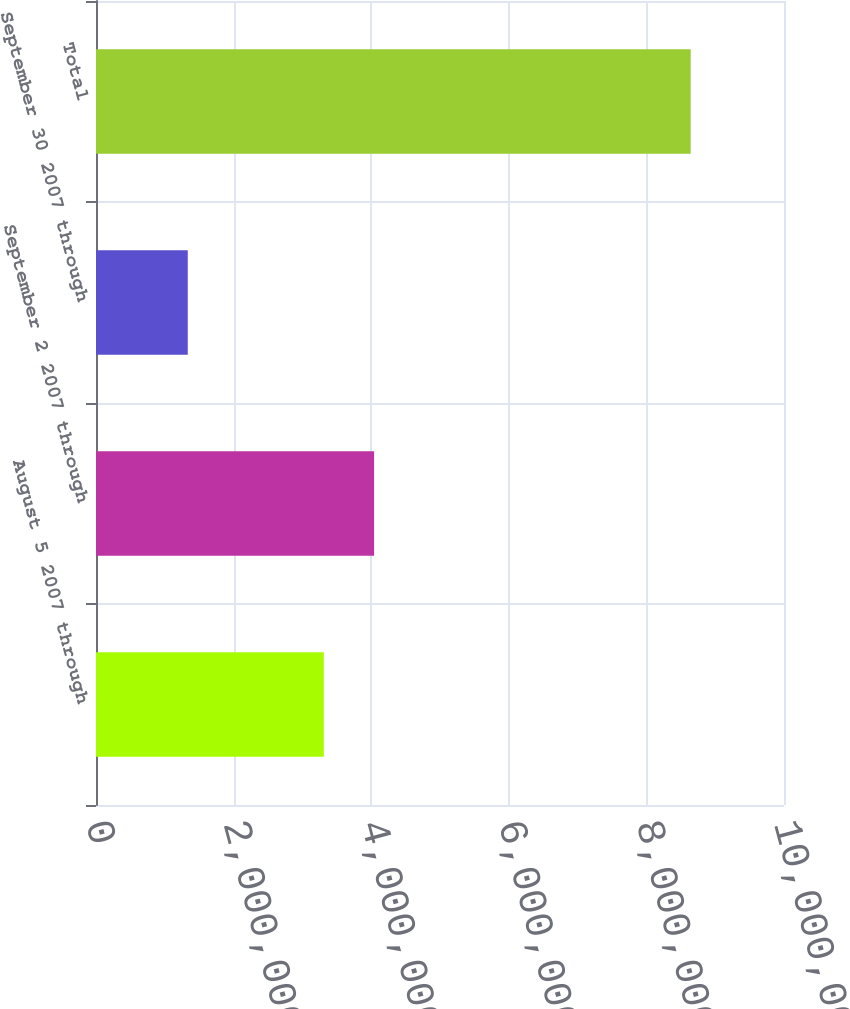Convert chart. <chart><loc_0><loc_0><loc_500><loc_500><bar_chart><fcel>August 5 2007 through<fcel>September 2 2007 through<fcel>September 30 2007 through<fcel>Total<nl><fcel>3.31077e+06<fcel>4.04176e+06<fcel>1.33377e+06<fcel>8.64373e+06<nl></chart> 